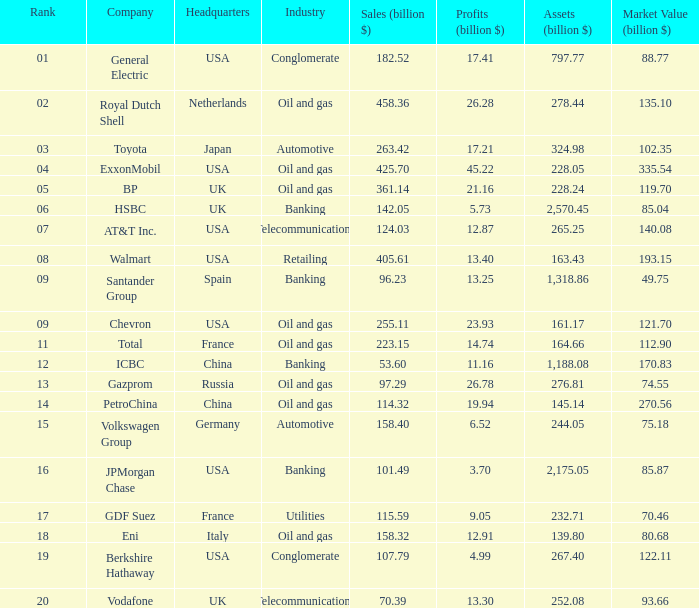Name the highest Profits (billion $) which has a Company of walmart? 13.4. 